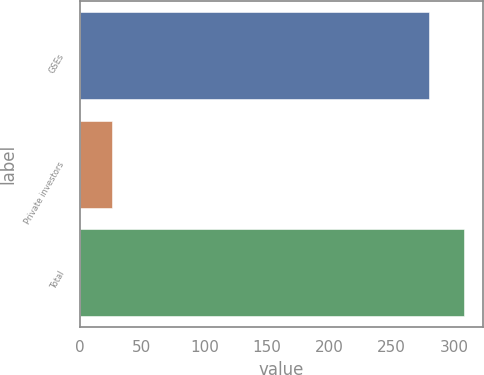Convert chart to OTSL. <chart><loc_0><loc_0><loc_500><loc_500><bar_chart><fcel>GSEs<fcel>Private investors<fcel>Total<nl><fcel>280<fcel>26<fcel>308<nl></chart> 